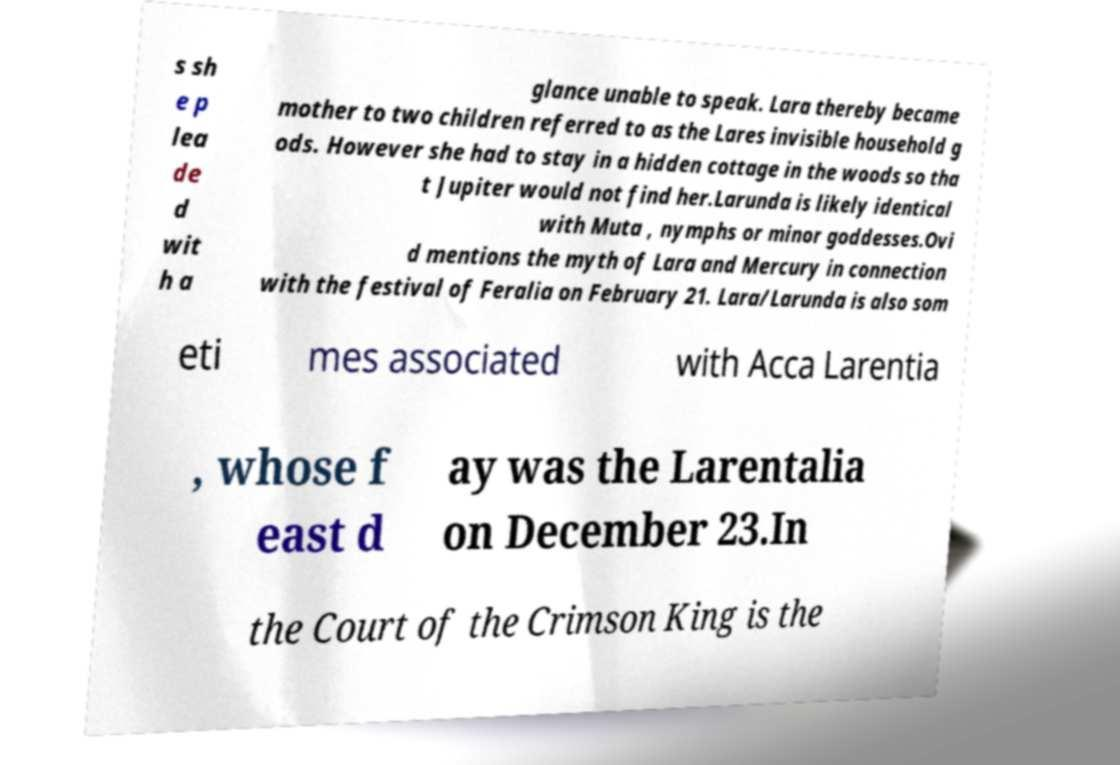Could you assist in decoding the text presented in this image and type it out clearly? s sh e p lea de d wit h a glance unable to speak. Lara thereby became mother to two children referred to as the Lares invisible household g ods. However she had to stay in a hidden cottage in the woods so tha t Jupiter would not find her.Larunda is likely identical with Muta , nymphs or minor goddesses.Ovi d mentions the myth of Lara and Mercury in connection with the festival of Feralia on February 21. Lara/Larunda is also som eti mes associated with Acca Larentia , whose f east d ay was the Larentalia on December 23.In the Court of the Crimson King is the 